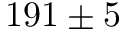<formula> <loc_0><loc_0><loc_500><loc_500>1 9 1 \pm 5</formula> 